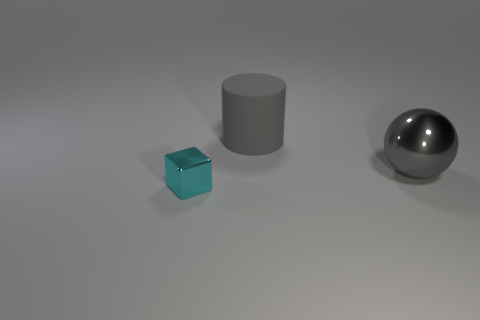What can you infer about the material properties of the objects? The gray cylinder and the shiny sphere suggest they're likely made of metal due to their reflective qualities. In contrast, the blue cube has a matte finish that could be indicative of a plastic or painted material. 